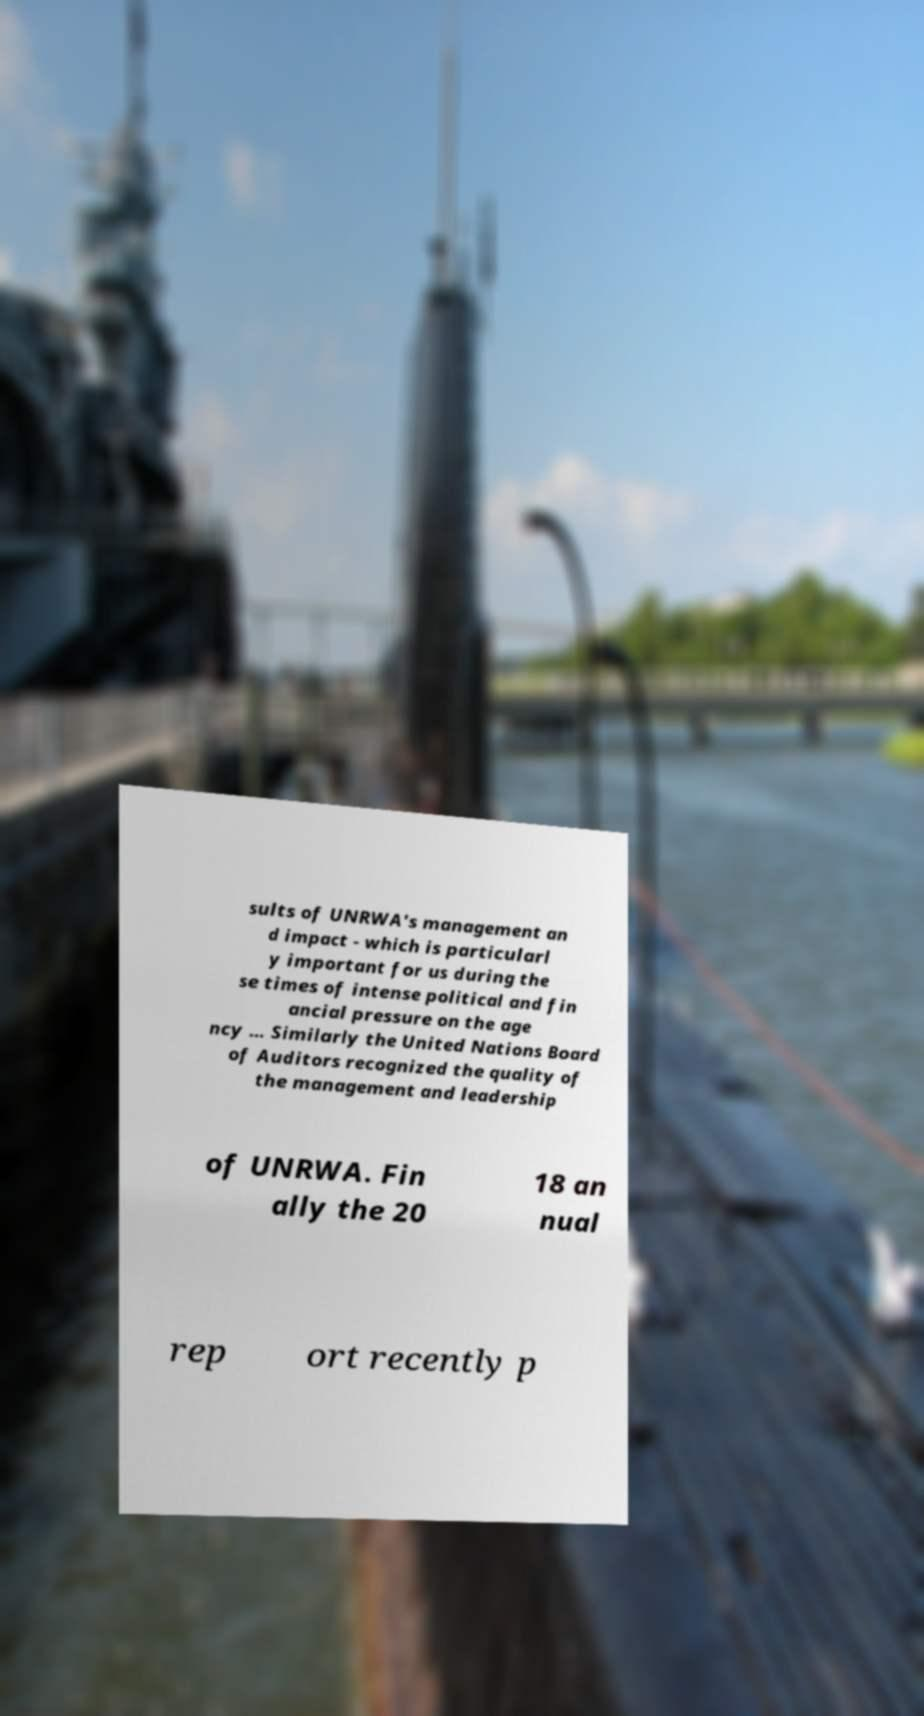Can you read and provide the text displayed in the image?This photo seems to have some interesting text. Can you extract and type it out for me? sults of UNRWA's management an d impact - which is particularl y important for us during the se times of intense political and fin ancial pressure on the age ncy ... Similarly the United Nations Board of Auditors recognized the quality of the management and leadership of UNRWA. Fin ally the 20 18 an nual rep ort recently p 